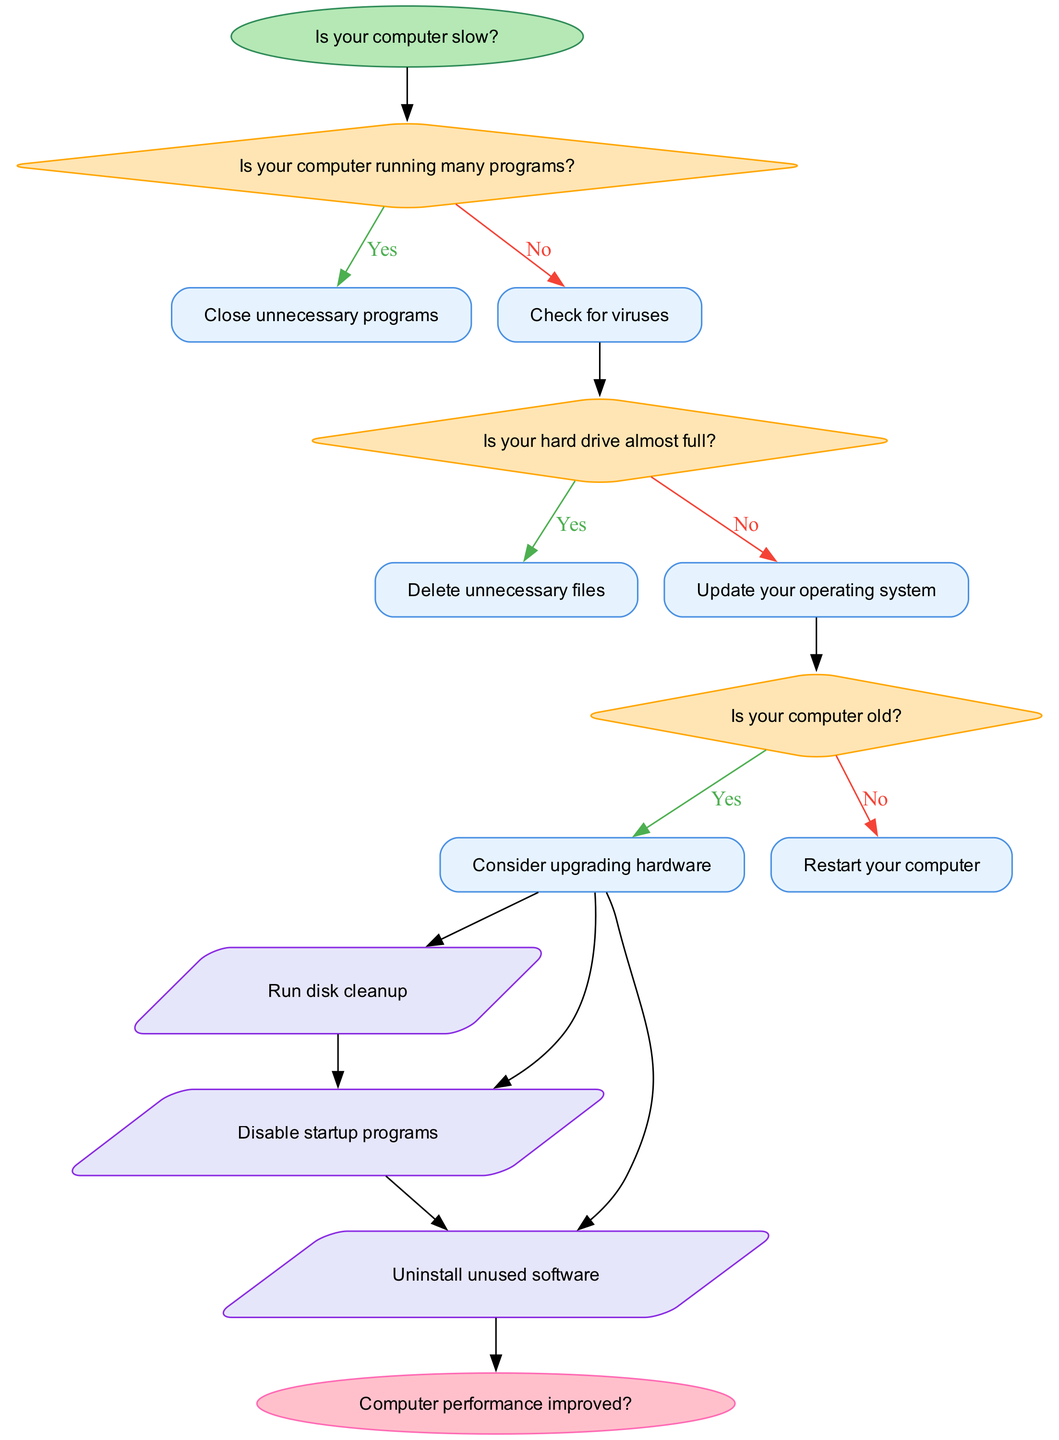What is the starting question in the flow chart? The starting question in the flow chart is at the "Start" node, which asks, "Is your computer slow?"
Answer: Is your computer slow? How many decision points are in the flow chart? There are three decision points listed in the flow chart, each corresponding to a different question about the computer's condition.
Answer: 3 What action follows the last decision point if answered "Yes"? If the last decision point is answered "Yes," the action that follows is to "Consider upgrading hardware."
Answer: Consider upgrading hardware What is the action taken if the computer is running many programs? If the computer is running many programs, the action to be taken is to "Close unnecessary programs."
Answer: Close unnecessary programs What happens if the hard drive is not almost full? If the hard drive is not almost full, the next action is to "Update your operating system."
Answer: Update your operating system Which option is taken if the computer is old after the last decision? If the computer is old and the last decision is answered "Yes," the flow suggests to "Consider upgrading hardware."
Answer: Consider upgrading hardware What is the final node of the flow chart? The final node of the flow chart is an "End" node that asks, "Computer performance improved?"
Answer: Computer performance improved? What does the flow diagram suggest if the answer to the last question is "No"? If the answer to the last question is "No," it suggests that the user should potentially revisit previous steps or actions which are not explicitly defined in this flow. However, it does imply the troubleshooting may require further inspection.
Answer: Revisit steps 